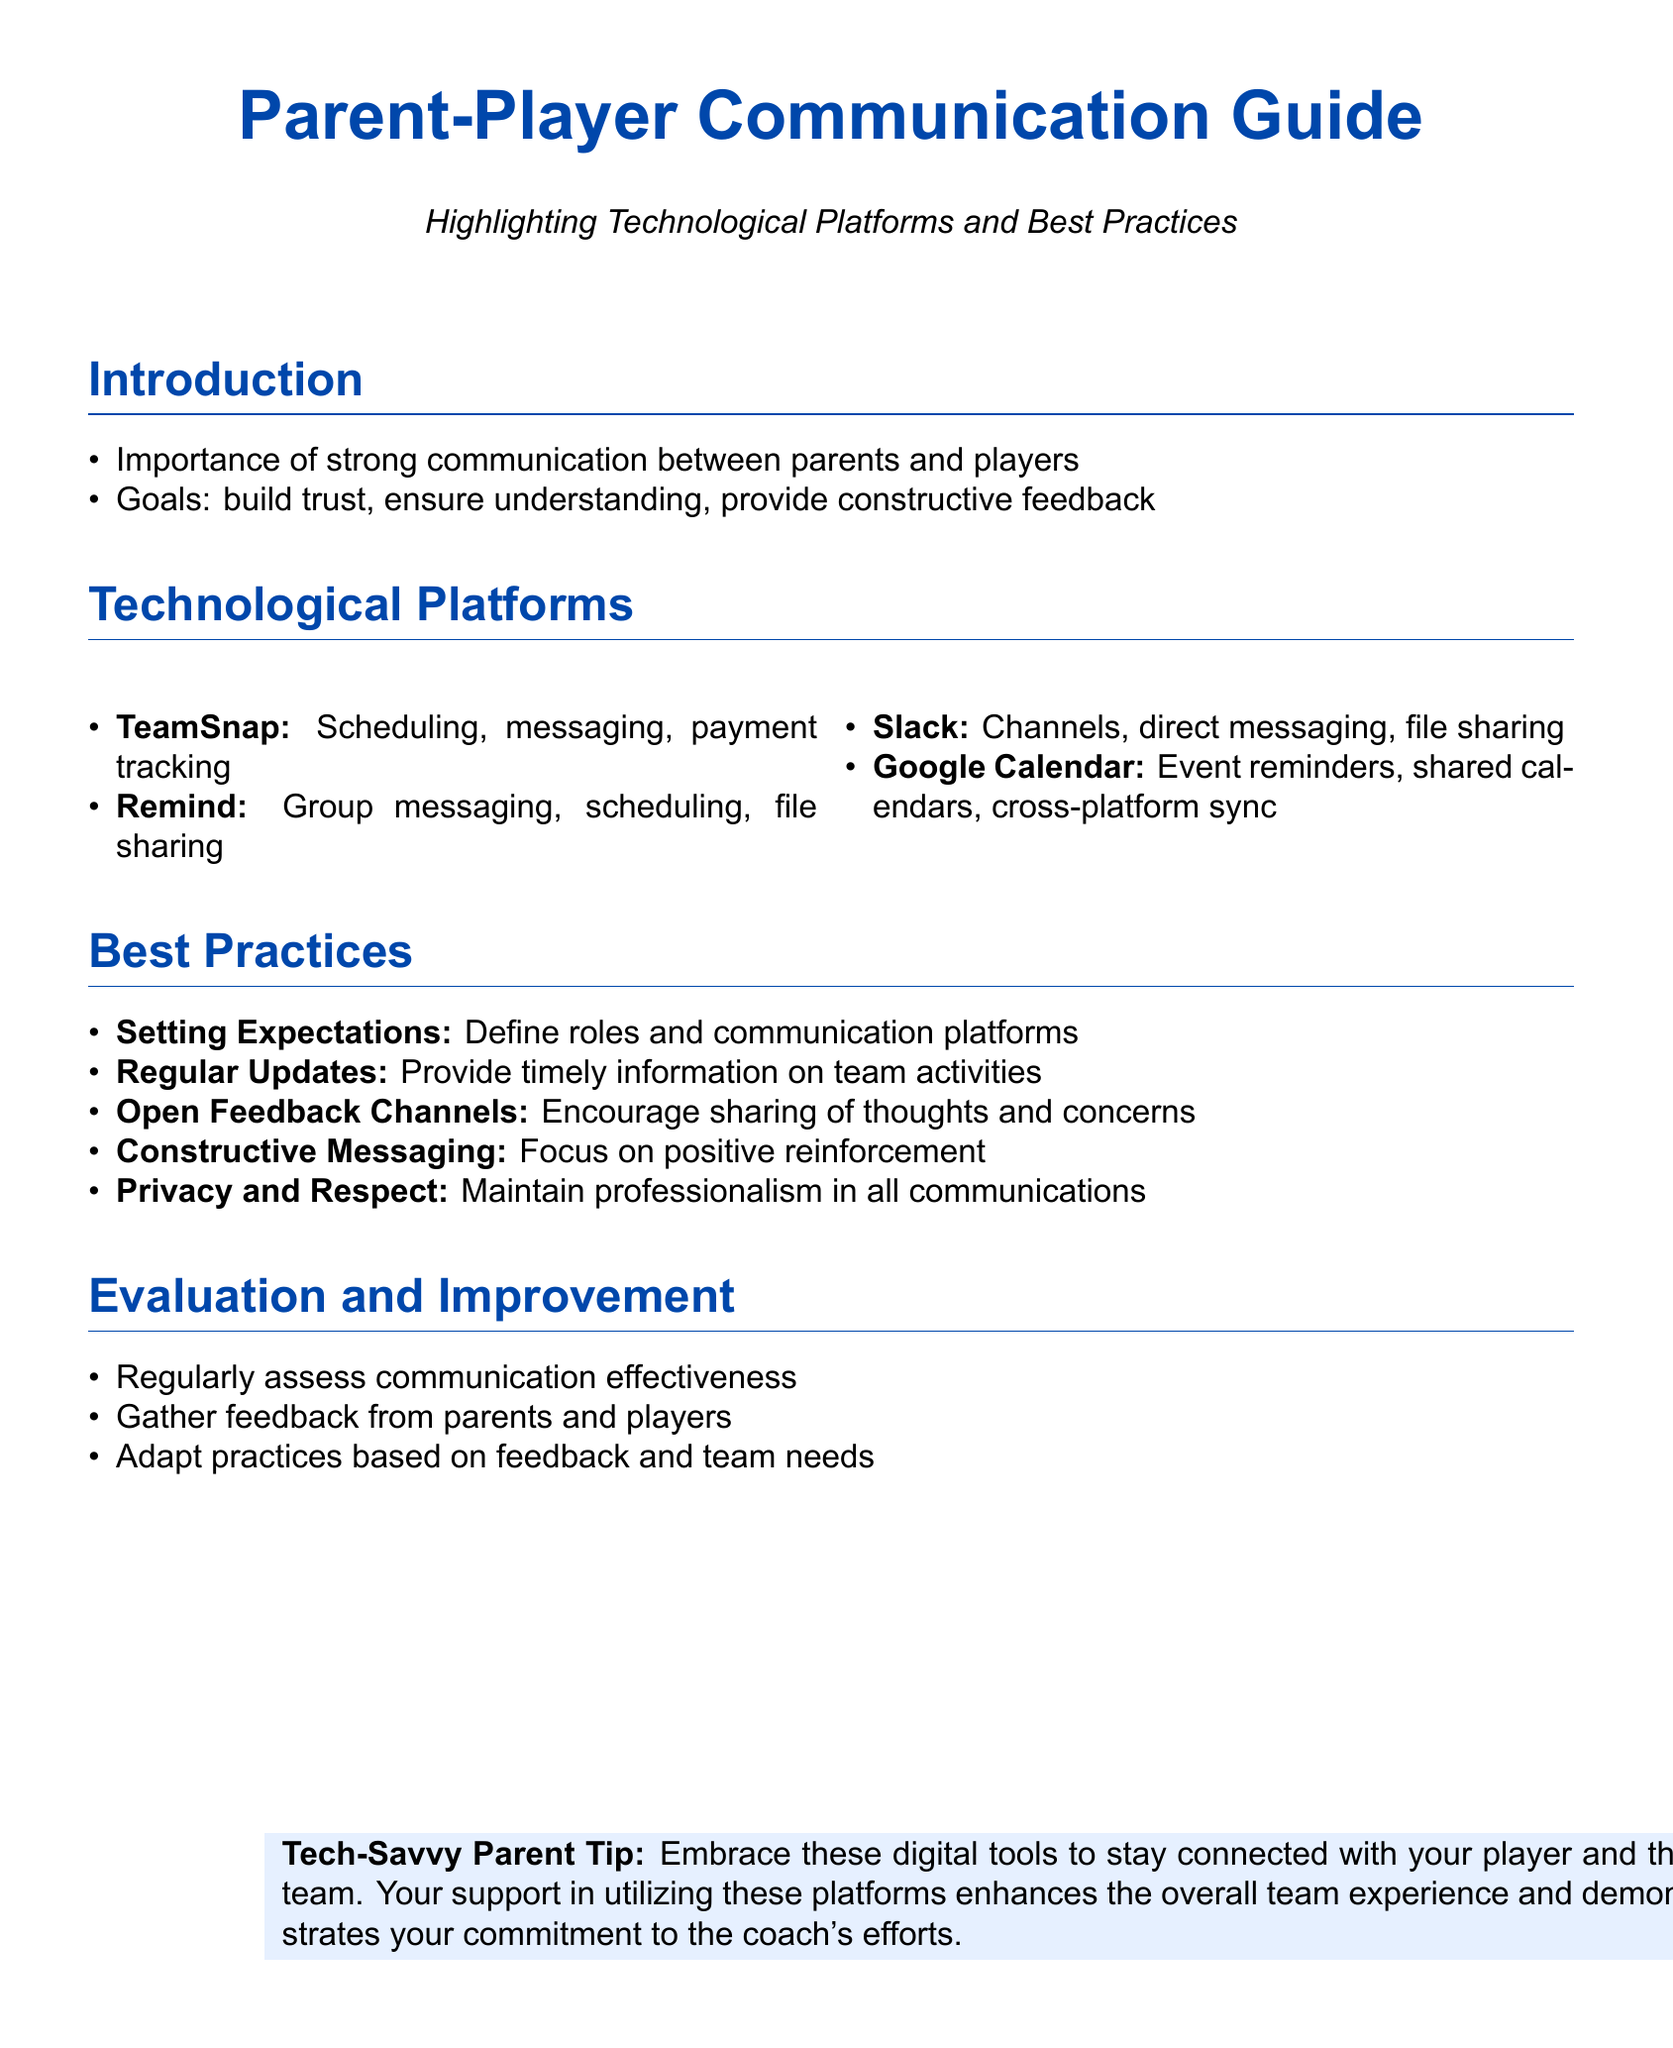What is the title of the document? The title is presented prominently at the top of the document, indicating its focus on parent-player communication.
Answer: Parent-Player Communication Guide What is the main purpose of the guide? The guide outlines the significance of communication between parents and players, as described in the introduction.
Answer: Build trust Which technological platform is used for scheduling, messaging, and payment tracking? The guide lists technological platforms with their specific features under the Technological Platforms section.
Answer: TeamSnap How many technological platforms are mentioned in the document? The document lists various platforms, which can be counted in the Technological Platforms section.
Answer: Four What is the first best practice listed in the guide? The best practices are outlined in an itemized list, and the first item is discussed under Best Practices.
Answer: Setting Expectations What type of feedback does the guide encourage? The document specifies the kind of communication that should be fostered among parents and players.
Answer: Open Feedback Channels What is the color of the footer tip? The color of the footer tip is indicated in the design elements described within the document.
Answer: Light blue What should be maintained in all communications? The guide emphasizes this concept within the Best Practices section.
Answer: Privacy and Respect 